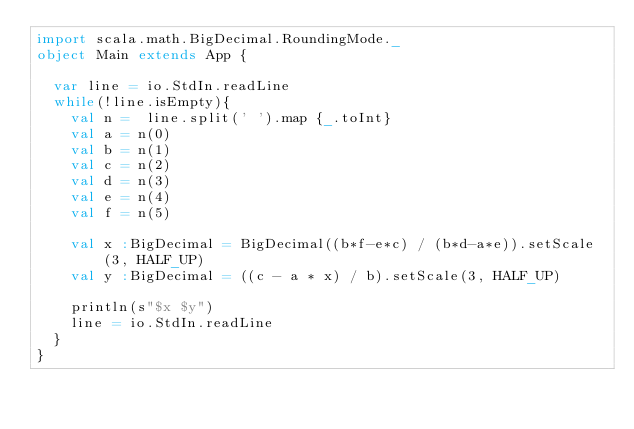<code> <loc_0><loc_0><loc_500><loc_500><_Scala_>import scala.math.BigDecimal.RoundingMode._
object Main extends App {

  var line = io.StdIn.readLine
  while(!line.isEmpty){
    val n =  line.split(' ').map {_.toInt}
    val a = n(0)
    val b = n(1)
    val c = n(2)
    val d = n(3)
    val e = n(4)
    val f = n(5)

    val x :BigDecimal = BigDecimal((b*f-e*c) / (b*d-a*e)).setScale(3, HALF_UP)
    val y :BigDecimal = ((c - a * x) / b).setScale(3, HALF_UP)

    println(s"$x $y")
    line = io.StdIn.readLine
  }
}</code> 